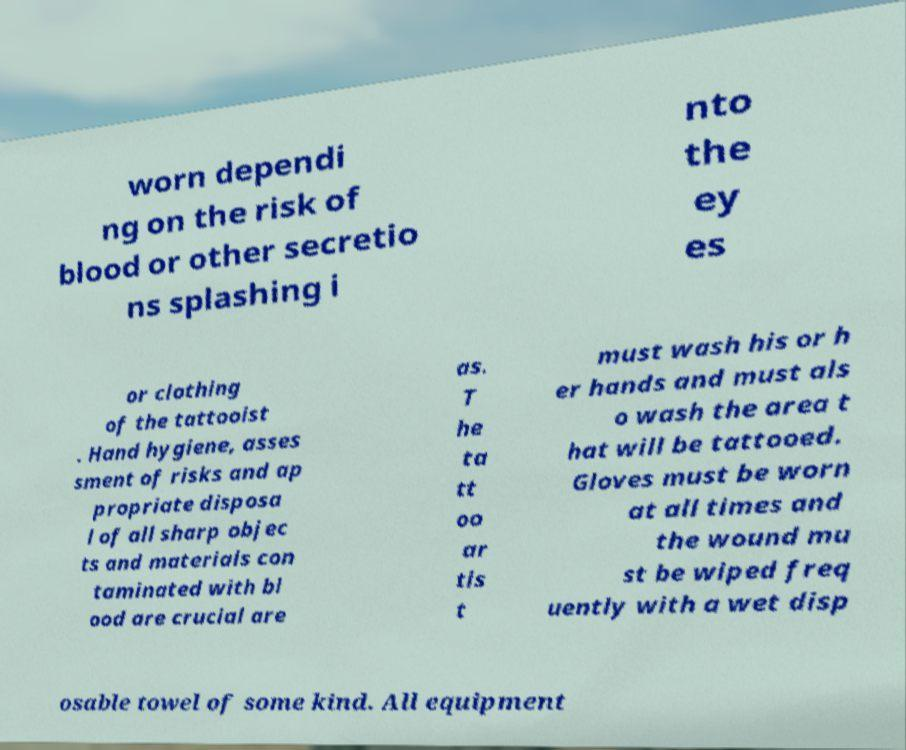Could you assist in decoding the text presented in this image and type it out clearly? worn dependi ng on the risk of blood or other secretio ns splashing i nto the ey es or clothing of the tattooist . Hand hygiene, asses sment of risks and ap propriate disposa l of all sharp objec ts and materials con taminated with bl ood are crucial are as. T he ta tt oo ar tis t must wash his or h er hands and must als o wash the area t hat will be tattooed. Gloves must be worn at all times and the wound mu st be wiped freq uently with a wet disp osable towel of some kind. All equipment 